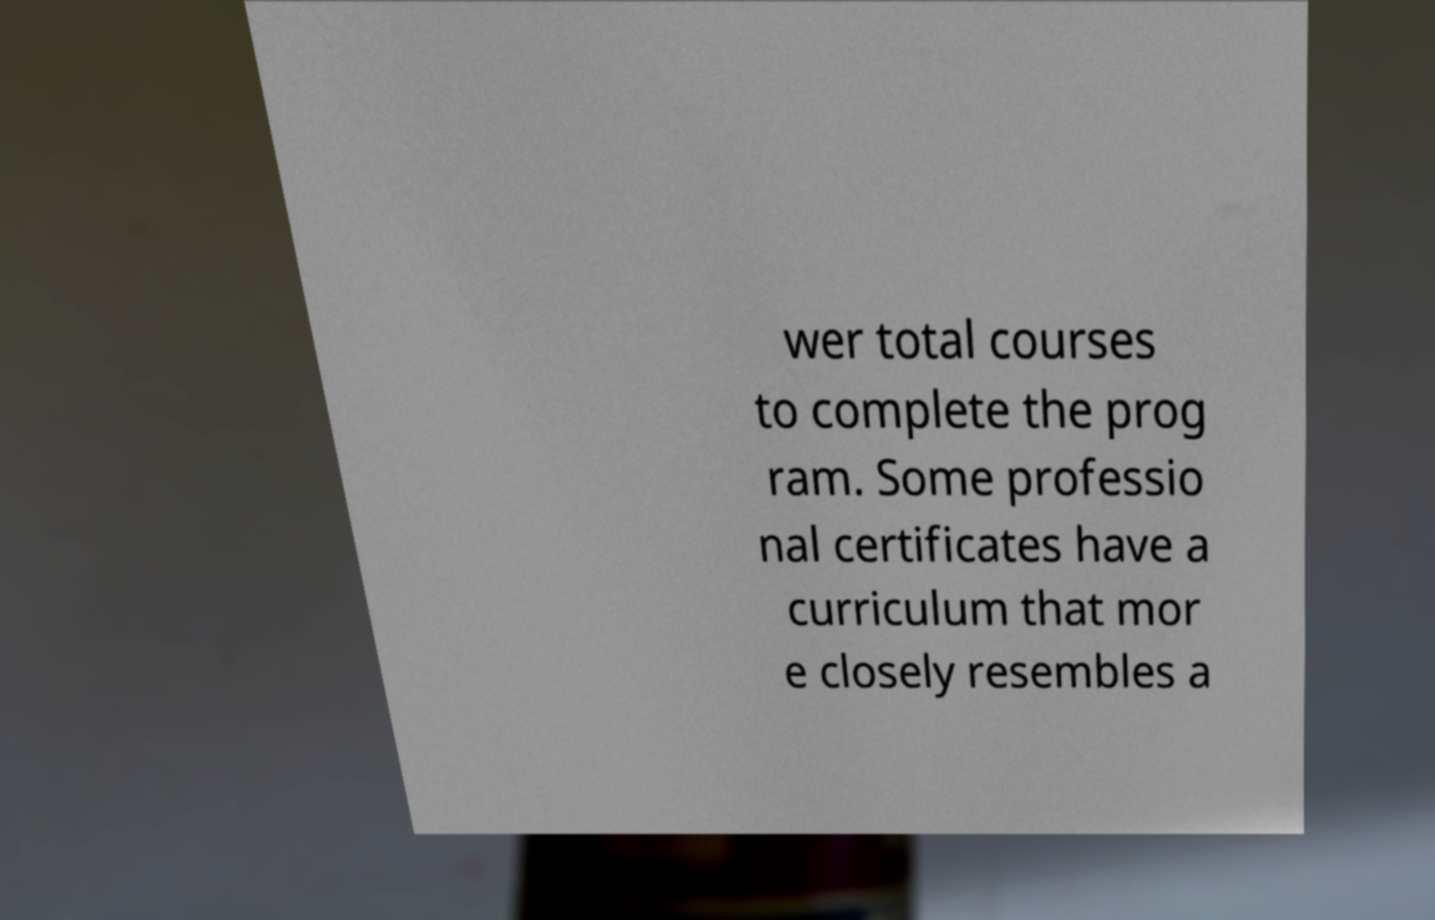Could you assist in decoding the text presented in this image and type it out clearly? wer total courses to complete the prog ram. Some professio nal certificates have a curriculum that mor e closely resembles a 